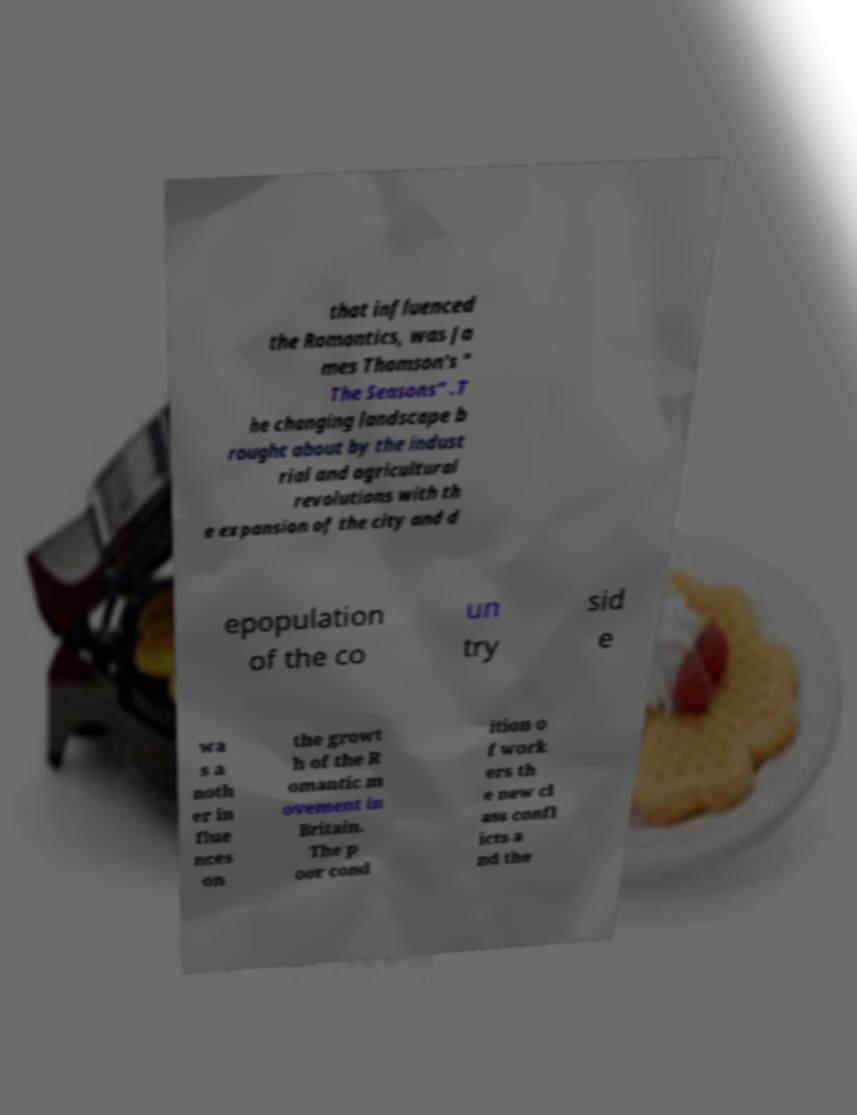Could you assist in decoding the text presented in this image and type it out clearly? that influenced the Romantics, was Ja mes Thomson's " The Seasons" .T he changing landscape b rought about by the indust rial and agricultural revolutions with th e expansion of the city and d epopulation of the co un try sid e wa s a noth er in flue nces on the growt h of the R omantic m ovement in Britain. The p oor cond ition o f work ers th e new cl ass confl icts a nd the 